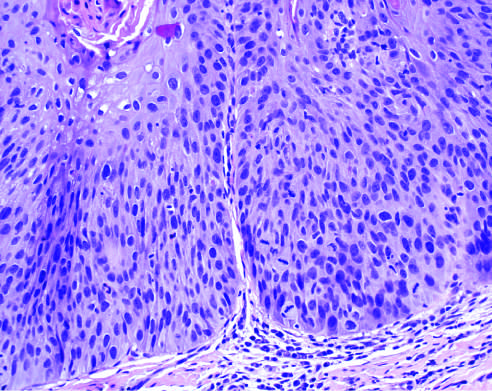how is histologic appearance of leukoplakia showing dysplasia characterized?
Answer the question using a single word or phrase. By nuclear and cellular pleomorphism and loss of normal maturation 